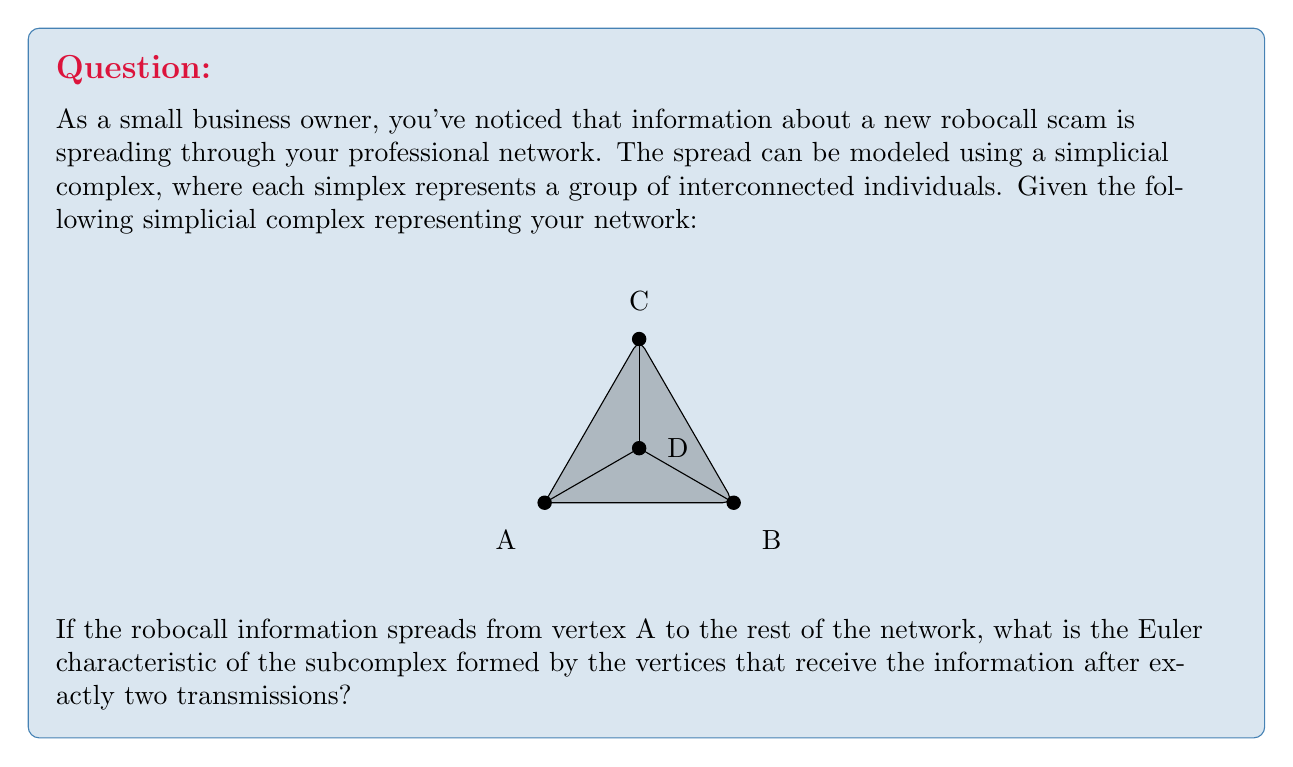Could you help me with this problem? Let's approach this step-by-step:

1) First, we need to understand how the information spreads:
   - Initially, only vertex A has the information.
   - After one transmission, vertices B and C receive the information (they are directly connected to A).
   - After two transmissions, vertex D receives the information (it's connected to B and C, which got the info in the first transmission).

2) The subcomplex formed by the vertices that receive the information after exactly two transmissions consists only of vertex D.

3) To calculate the Euler characteristic, we use the formula:
   $$\chi = V - E + F - T$$
   Where:
   $V$ = number of vertices
   $E$ = number of edges
   $F$ = number of faces
   $T$ = number of tetrahedra

4) For our subcomplex:
   $V = 1$ (only vertex D)
   $E = 0$ (no edges in this subcomplex)
   $F = 0$ (no faces)
   $T = 0$ (no tetrahedra)

5) Substituting into the formula:
   $$\chi = 1 - 0 + 0 - 0 = 1$$

Therefore, the Euler characteristic of the subcomplex is 1.
Answer: 1 